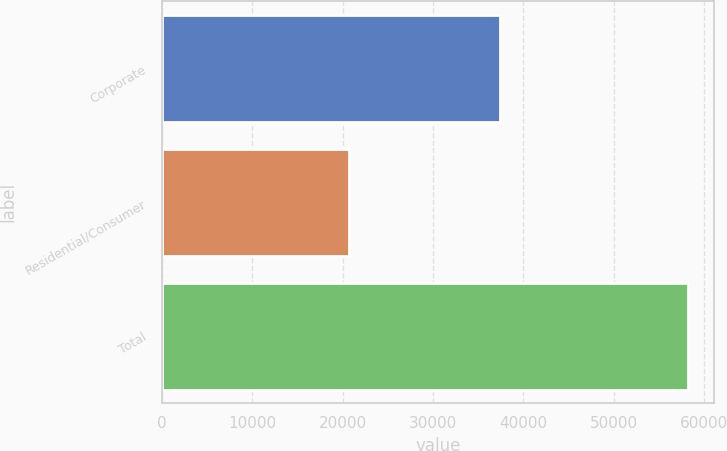Convert chart to OTSL. <chart><loc_0><loc_0><loc_500><loc_500><bar_chart><fcel>Corporate<fcel>Residential/Consumer<fcel>Total<nl><fcel>37462<fcel>20702<fcel>58164<nl></chart> 